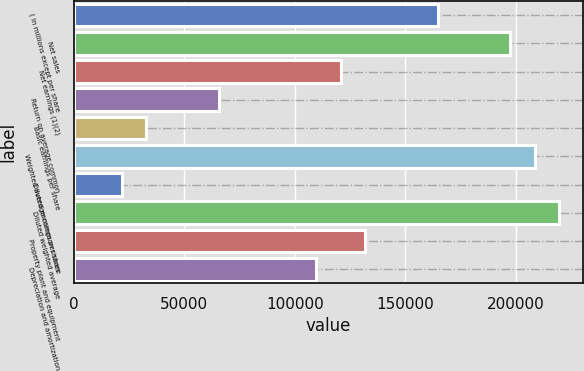Convert chart. <chart><loc_0><loc_0><loc_500><loc_500><bar_chart><fcel>( in millions except per share<fcel>Net sales<fcel>Net earnings (1)(2)<fcel>Return on average common<fcel>Basic earnings per share<fcel>Weighted average common shares<fcel>Diluted earnings per share<fcel>Diluted weighted average<fcel>Property plant and equipment<fcel>Depreciation and amortization<nl><fcel>164598<fcel>197517<fcel>120705<fcel>65839.4<fcel>32919.9<fcel>208490<fcel>21946.7<fcel>219464<fcel>131678<fcel>109732<nl></chart> 